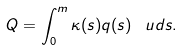<formula> <loc_0><loc_0><loc_500><loc_500>Q = \int _ { 0 } ^ { m } \kappa ( s ) q ( s ) \, \ u d s .</formula> 